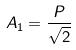<formula> <loc_0><loc_0><loc_500><loc_500>A _ { 1 } = \frac { P } { \sqrt { 2 } }</formula> 